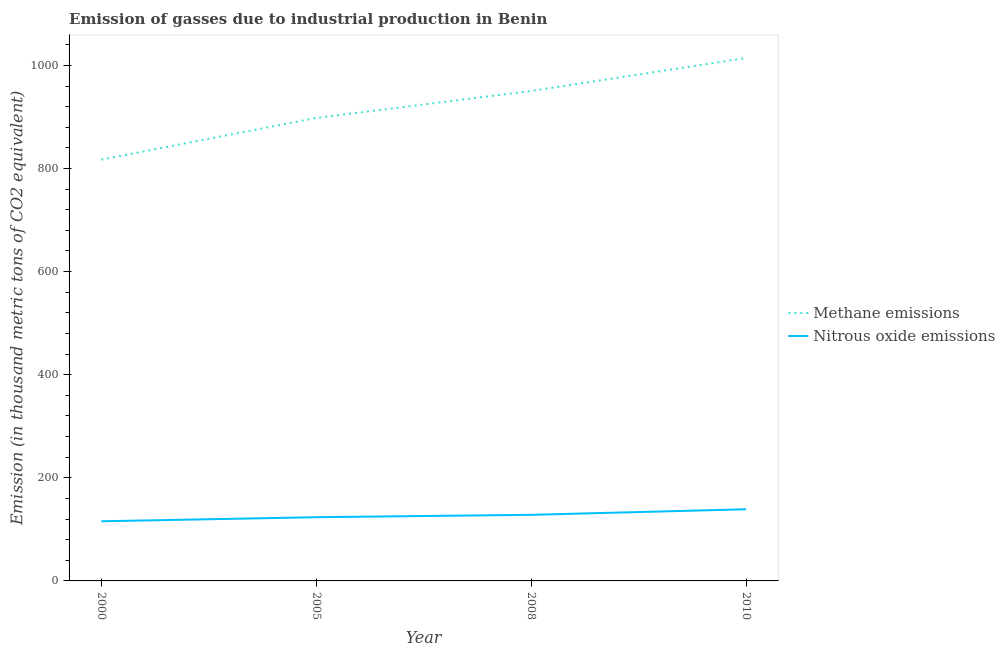Is the number of lines equal to the number of legend labels?
Provide a succinct answer. Yes. What is the amount of nitrous oxide emissions in 2000?
Your response must be concise. 115.7. Across all years, what is the maximum amount of methane emissions?
Your response must be concise. 1014.3. Across all years, what is the minimum amount of nitrous oxide emissions?
Give a very brief answer. 115.7. In which year was the amount of nitrous oxide emissions maximum?
Your response must be concise. 2010. What is the total amount of methane emissions in the graph?
Give a very brief answer. 3680. What is the difference between the amount of nitrous oxide emissions in 2005 and that in 2010?
Your answer should be compact. -15.4. What is the difference between the amount of nitrous oxide emissions in 2008 and the amount of methane emissions in 2000?
Your response must be concise. -689. What is the average amount of nitrous oxide emissions per year?
Keep it short and to the point. 126.62. In the year 2010, what is the difference between the amount of nitrous oxide emissions and amount of methane emissions?
Your answer should be compact. -875.3. What is the ratio of the amount of methane emissions in 2000 to that in 2005?
Your answer should be compact. 0.91. What is the difference between the highest and the second highest amount of nitrous oxide emissions?
Your answer should be very brief. 10.8. What is the difference between the highest and the lowest amount of methane emissions?
Keep it short and to the point. 197.1. In how many years, is the amount of methane emissions greater than the average amount of methane emissions taken over all years?
Keep it short and to the point. 2. Is the sum of the amount of methane emissions in 2005 and 2008 greater than the maximum amount of nitrous oxide emissions across all years?
Your answer should be compact. Yes. Does the amount of nitrous oxide emissions monotonically increase over the years?
Make the answer very short. Yes. Is the amount of nitrous oxide emissions strictly less than the amount of methane emissions over the years?
Your answer should be very brief. Yes. How many years are there in the graph?
Give a very brief answer. 4. Where does the legend appear in the graph?
Keep it short and to the point. Center right. What is the title of the graph?
Your answer should be compact. Emission of gasses due to industrial production in Benin. Does "Boys" appear as one of the legend labels in the graph?
Offer a very short reply. No. What is the label or title of the X-axis?
Ensure brevity in your answer.  Year. What is the label or title of the Y-axis?
Keep it short and to the point. Emission (in thousand metric tons of CO2 equivalent). What is the Emission (in thousand metric tons of CO2 equivalent) of Methane emissions in 2000?
Ensure brevity in your answer.  817.2. What is the Emission (in thousand metric tons of CO2 equivalent) of Nitrous oxide emissions in 2000?
Offer a very short reply. 115.7. What is the Emission (in thousand metric tons of CO2 equivalent) of Methane emissions in 2005?
Ensure brevity in your answer.  898.1. What is the Emission (in thousand metric tons of CO2 equivalent) of Nitrous oxide emissions in 2005?
Provide a short and direct response. 123.6. What is the Emission (in thousand metric tons of CO2 equivalent) in Methane emissions in 2008?
Provide a short and direct response. 950.4. What is the Emission (in thousand metric tons of CO2 equivalent) in Nitrous oxide emissions in 2008?
Provide a succinct answer. 128.2. What is the Emission (in thousand metric tons of CO2 equivalent) in Methane emissions in 2010?
Offer a terse response. 1014.3. What is the Emission (in thousand metric tons of CO2 equivalent) in Nitrous oxide emissions in 2010?
Provide a short and direct response. 139. Across all years, what is the maximum Emission (in thousand metric tons of CO2 equivalent) of Methane emissions?
Provide a succinct answer. 1014.3. Across all years, what is the maximum Emission (in thousand metric tons of CO2 equivalent) of Nitrous oxide emissions?
Your answer should be very brief. 139. Across all years, what is the minimum Emission (in thousand metric tons of CO2 equivalent) of Methane emissions?
Offer a very short reply. 817.2. Across all years, what is the minimum Emission (in thousand metric tons of CO2 equivalent) in Nitrous oxide emissions?
Offer a terse response. 115.7. What is the total Emission (in thousand metric tons of CO2 equivalent) of Methane emissions in the graph?
Make the answer very short. 3680. What is the total Emission (in thousand metric tons of CO2 equivalent) in Nitrous oxide emissions in the graph?
Your answer should be compact. 506.5. What is the difference between the Emission (in thousand metric tons of CO2 equivalent) in Methane emissions in 2000 and that in 2005?
Offer a terse response. -80.9. What is the difference between the Emission (in thousand metric tons of CO2 equivalent) in Nitrous oxide emissions in 2000 and that in 2005?
Make the answer very short. -7.9. What is the difference between the Emission (in thousand metric tons of CO2 equivalent) of Methane emissions in 2000 and that in 2008?
Offer a terse response. -133.2. What is the difference between the Emission (in thousand metric tons of CO2 equivalent) in Methane emissions in 2000 and that in 2010?
Keep it short and to the point. -197.1. What is the difference between the Emission (in thousand metric tons of CO2 equivalent) in Nitrous oxide emissions in 2000 and that in 2010?
Offer a very short reply. -23.3. What is the difference between the Emission (in thousand metric tons of CO2 equivalent) in Methane emissions in 2005 and that in 2008?
Ensure brevity in your answer.  -52.3. What is the difference between the Emission (in thousand metric tons of CO2 equivalent) in Nitrous oxide emissions in 2005 and that in 2008?
Your answer should be very brief. -4.6. What is the difference between the Emission (in thousand metric tons of CO2 equivalent) of Methane emissions in 2005 and that in 2010?
Offer a terse response. -116.2. What is the difference between the Emission (in thousand metric tons of CO2 equivalent) in Nitrous oxide emissions in 2005 and that in 2010?
Offer a terse response. -15.4. What is the difference between the Emission (in thousand metric tons of CO2 equivalent) in Methane emissions in 2008 and that in 2010?
Provide a succinct answer. -63.9. What is the difference between the Emission (in thousand metric tons of CO2 equivalent) of Nitrous oxide emissions in 2008 and that in 2010?
Offer a terse response. -10.8. What is the difference between the Emission (in thousand metric tons of CO2 equivalent) in Methane emissions in 2000 and the Emission (in thousand metric tons of CO2 equivalent) in Nitrous oxide emissions in 2005?
Ensure brevity in your answer.  693.6. What is the difference between the Emission (in thousand metric tons of CO2 equivalent) in Methane emissions in 2000 and the Emission (in thousand metric tons of CO2 equivalent) in Nitrous oxide emissions in 2008?
Give a very brief answer. 689. What is the difference between the Emission (in thousand metric tons of CO2 equivalent) of Methane emissions in 2000 and the Emission (in thousand metric tons of CO2 equivalent) of Nitrous oxide emissions in 2010?
Provide a short and direct response. 678.2. What is the difference between the Emission (in thousand metric tons of CO2 equivalent) of Methane emissions in 2005 and the Emission (in thousand metric tons of CO2 equivalent) of Nitrous oxide emissions in 2008?
Give a very brief answer. 769.9. What is the difference between the Emission (in thousand metric tons of CO2 equivalent) in Methane emissions in 2005 and the Emission (in thousand metric tons of CO2 equivalent) in Nitrous oxide emissions in 2010?
Offer a terse response. 759.1. What is the difference between the Emission (in thousand metric tons of CO2 equivalent) of Methane emissions in 2008 and the Emission (in thousand metric tons of CO2 equivalent) of Nitrous oxide emissions in 2010?
Keep it short and to the point. 811.4. What is the average Emission (in thousand metric tons of CO2 equivalent) in Methane emissions per year?
Offer a very short reply. 920. What is the average Emission (in thousand metric tons of CO2 equivalent) in Nitrous oxide emissions per year?
Ensure brevity in your answer.  126.62. In the year 2000, what is the difference between the Emission (in thousand metric tons of CO2 equivalent) of Methane emissions and Emission (in thousand metric tons of CO2 equivalent) of Nitrous oxide emissions?
Offer a terse response. 701.5. In the year 2005, what is the difference between the Emission (in thousand metric tons of CO2 equivalent) in Methane emissions and Emission (in thousand metric tons of CO2 equivalent) in Nitrous oxide emissions?
Your answer should be compact. 774.5. In the year 2008, what is the difference between the Emission (in thousand metric tons of CO2 equivalent) of Methane emissions and Emission (in thousand metric tons of CO2 equivalent) of Nitrous oxide emissions?
Offer a very short reply. 822.2. In the year 2010, what is the difference between the Emission (in thousand metric tons of CO2 equivalent) in Methane emissions and Emission (in thousand metric tons of CO2 equivalent) in Nitrous oxide emissions?
Your response must be concise. 875.3. What is the ratio of the Emission (in thousand metric tons of CO2 equivalent) in Methane emissions in 2000 to that in 2005?
Ensure brevity in your answer.  0.91. What is the ratio of the Emission (in thousand metric tons of CO2 equivalent) of Nitrous oxide emissions in 2000 to that in 2005?
Give a very brief answer. 0.94. What is the ratio of the Emission (in thousand metric tons of CO2 equivalent) of Methane emissions in 2000 to that in 2008?
Give a very brief answer. 0.86. What is the ratio of the Emission (in thousand metric tons of CO2 equivalent) of Nitrous oxide emissions in 2000 to that in 2008?
Give a very brief answer. 0.9. What is the ratio of the Emission (in thousand metric tons of CO2 equivalent) of Methane emissions in 2000 to that in 2010?
Your answer should be compact. 0.81. What is the ratio of the Emission (in thousand metric tons of CO2 equivalent) of Nitrous oxide emissions in 2000 to that in 2010?
Your answer should be compact. 0.83. What is the ratio of the Emission (in thousand metric tons of CO2 equivalent) of Methane emissions in 2005 to that in 2008?
Provide a short and direct response. 0.94. What is the ratio of the Emission (in thousand metric tons of CO2 equivalent) of Nitrous oxide emissions in 2005 to that in 2008?
Your answer should be compact. 0.96. What is the ratio of the Emission (in thousand metric tons of CO2 equivalent) of Methane emissions in 2005 to that in 2010?
Provide a succinct answer. 0.89. What is the ratio of the Emission (in thousand metric tons of CO2 equivalent) of Nitrous oxide emissions in 2005 to that in 2010?
Make the answer very short. 0.89. What is the ratio of the Emission (in thousand metric tons of CO2 equivalent) in Methane emissions in 2008 to that in 2010?
Your answer should be very brief. 0.94. What is the ratio of the Emission (in thousand metric tons of CO2 equivalent) in Nitrous oxide emissions in 2008 to that in 2010?
Offer a very short reply. 0.92. What is the difference between the highest and the second highest Emission (in thousand metric tons of CO2 equivalent) of Methane emissions?
Offer a terse response. 63.9. What is the difference between the highest and the lowest Emission (in thousand metric tons of CO2 equivalent) in Methane emissions?
Keep it short and to the point. 197.1. What is the difference between the highest and the lowest Emission (in thousand metric tons of CO2 equivalent) in Nitrous oxide emissions?
Offer a very short reply. 23.3. 